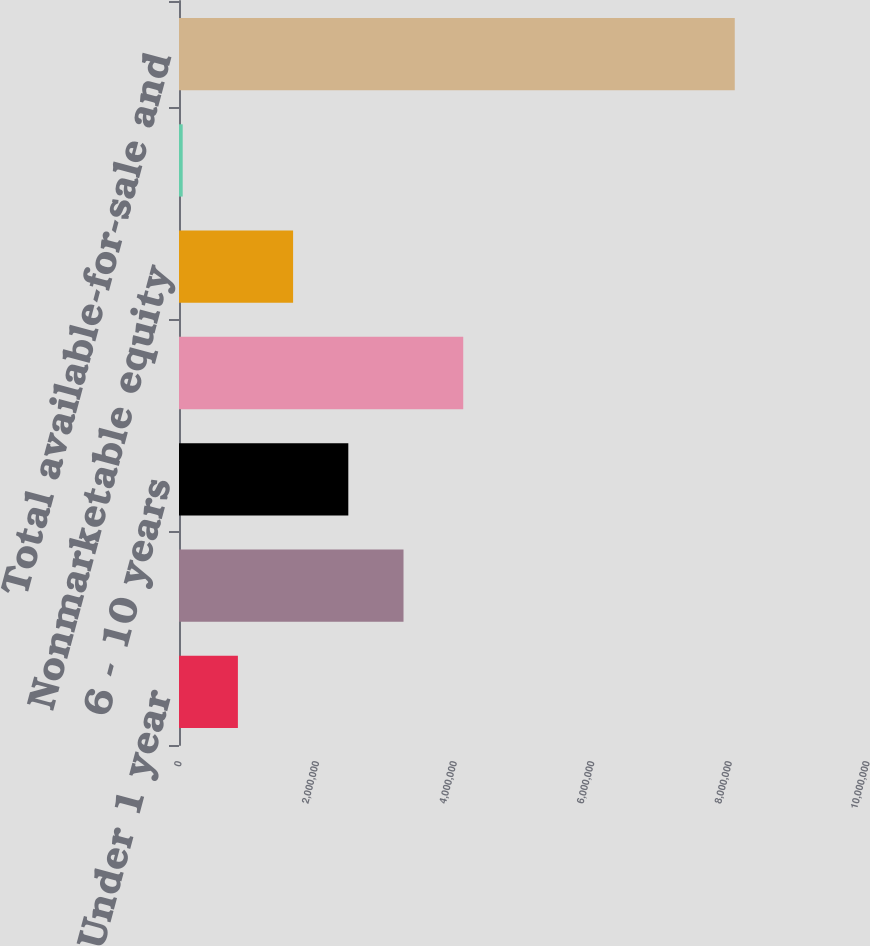Convert chart. <chart><loc_0><loc_0><loc_500><loc_500><bar_chart><fcel>Under 1 year<fcel>1 - 5 years<fcel>6 - 10 years<fcel>Over 10 years<fcel>Nonmarketable equity<fcel>Marketable equity securities<fcel>Total available-for-sale and<nl><fcel>856058<fcel>3.26338e+06<fcel>2.46094e+06<fcel>4.13124e+06<fcel>1.6585e+06<fcel>53619<fcel>8.07801e+06<nl></chart> 